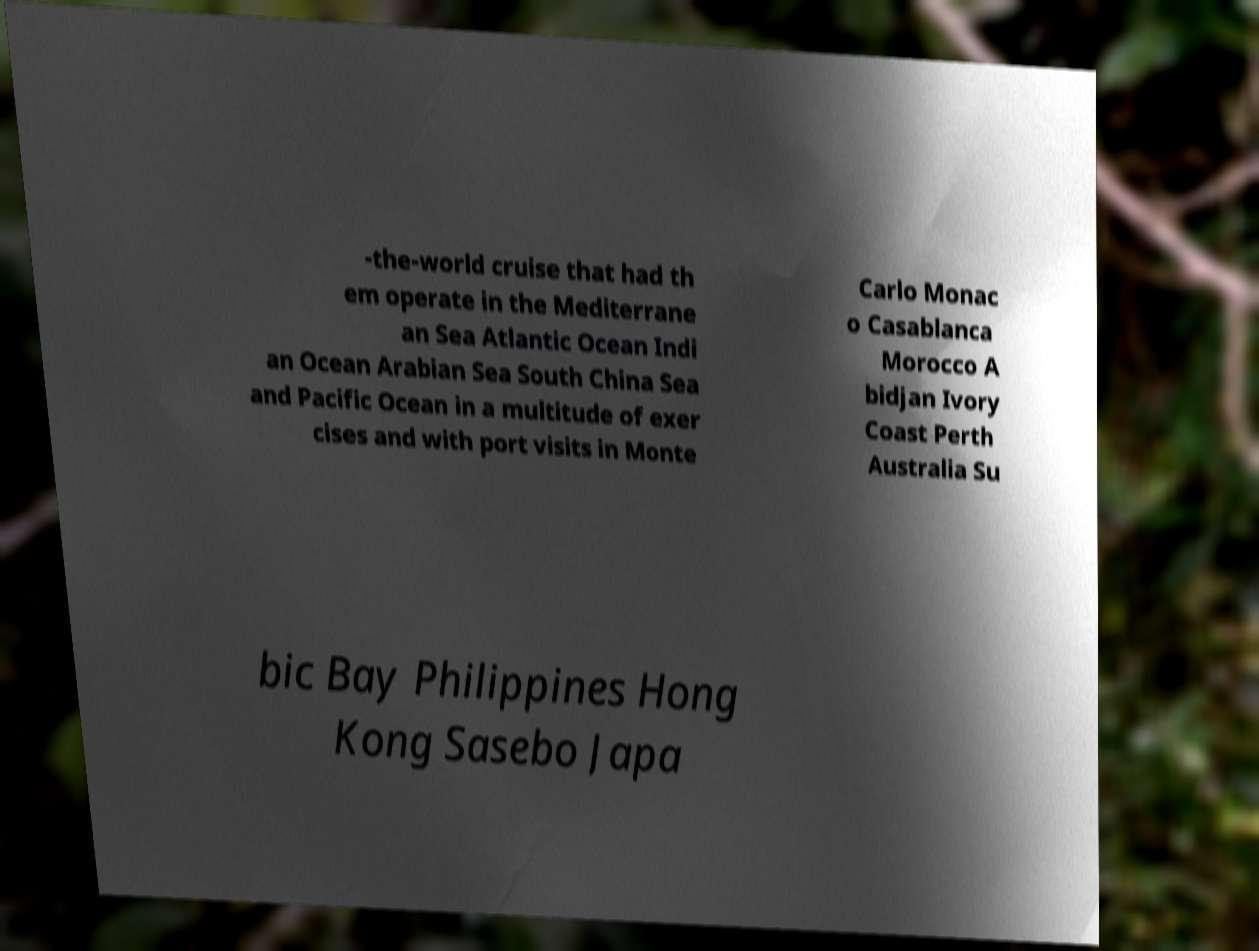Please read and relay the text visible in this image. What does it say? -the-world cruise that had th em operate in the Mediterrane an Sea Atlantic Ocean Indi an Ocean Arabian Sea South China Sea and Pacific Ocean in a multitude of exer cises and with port visits in Monte Carlo Monac o Casablanca Morocco A bidjan Ivory Coast Perth Australia Su bic Bay Philippines Hong Kong Sasebo Japa 